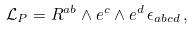Convert formula to latex. <formula><loc_0><loc_0><loc_500><loc_500>\mathcal { L } _ { P } = R ^ { a b } \wedge e ^ { c } \wedge e ^ { d } \, \epsilon _ { a b c d } \, ,</formula> 